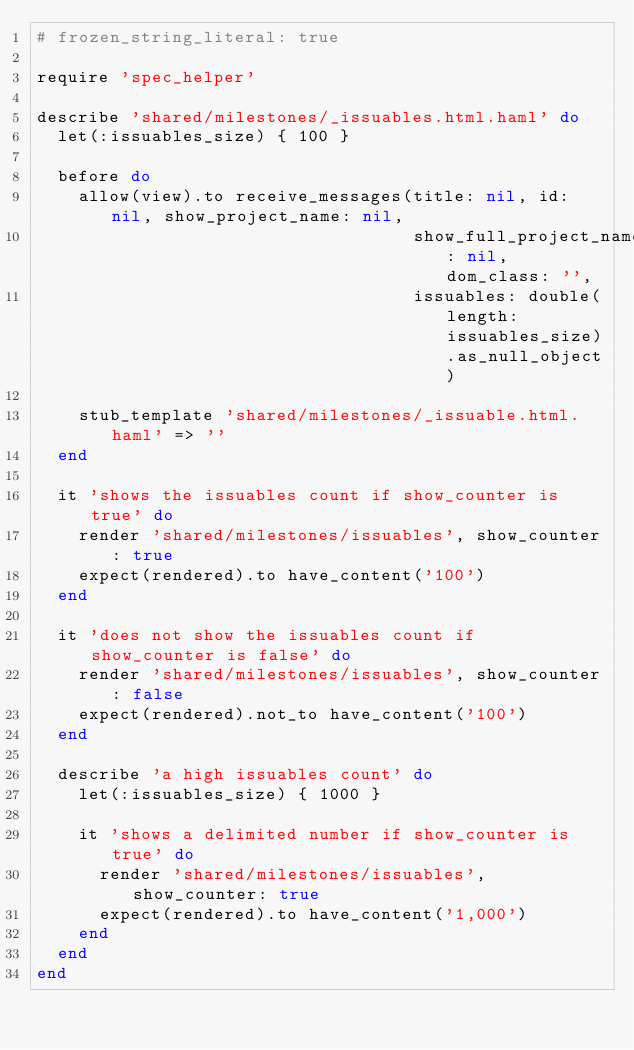Convert code to text. <code><loc_0><loc_0><loc_500><loc_500><_Ruby_># frozen_string_literal: true

require 'spec_helper'

describe 'shared/milestones/_issuables.html.haml' do
  let(:issuables_size) { 100 }

  before do
    allow(view).to receive_messages(title: nil, id: nil, show_project_name: nil,
                                    show_full_project_name: nil, dom_class: '',
                                    issuables: double(length: issuables_size).as_null_object)

    stub_template 'shared/milestones/_issuable.html.haml' => ''
  end

  it 'shows the issuables count if show_counter is true' do
    render 'shared/milestones/issuables', show_counter: true
    expect(rendered).to have_content('100')
  end

  it 'does not show the issuables count if show_counter is false' do
    render 'shared/milestones/issuables', show_counter: false
    expect(rendered).not_to have_content('100')
  end

  describe 'a high issuables count' do
    let(:issuables_size) { 1000 }

    it 'shows a delimited number if show_counter is true' do
      render 'shared/milestones/issuables', show_counter: true
      expect(rendered).to have_content('1,000')
    end
  end
end
</code> 